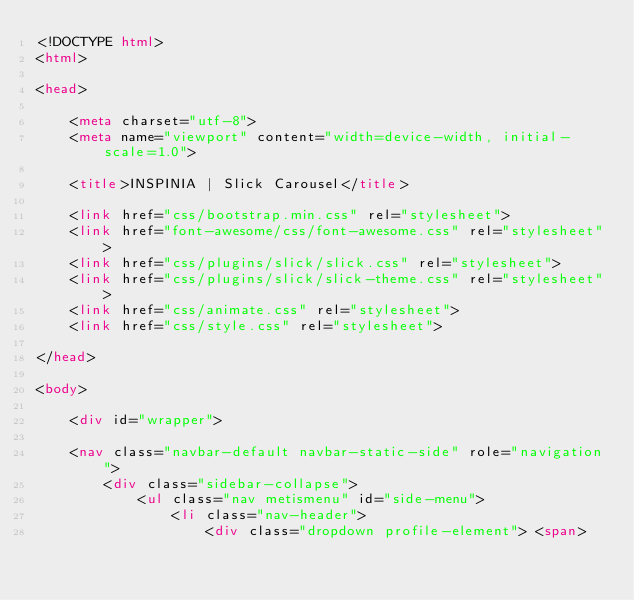<code> <loc_0><loc_0><loc_500><loc_500><_HTML_><!DOCTYPE html>
<html>

<head>

    <meta charset="utf-8">
    <meta name="viewport" content="width=device-width, initial-scale=1.0">

    <title>INSPINIA | Slick Carousel</title>

    <link href="css/bootstrap.min.css" rel="stylesheet">
    <link href="font-awesome/css/font-awesome.css" rel="stylesheet">
    <link href="css/plugins/slick/slick.css" rel="stylesheet">
    <link href="css/plugins/slick/slick-theme.css" rel="stylesheet">
    <link href="css/animate.css" rel="stylesheet">
    <link href="css/style.css" rel="stylesheet">

</head>

<body>

    <div id="wrapper">

    <nav class="navbar-default navbar-static-side" role="navigation">
        <div class="sidebar-collapse">
            <ul class="nav metismenu" id="side-menu">
                <li class="nav-header">
                    <div class="dropdown profile-element"> <span></code> 